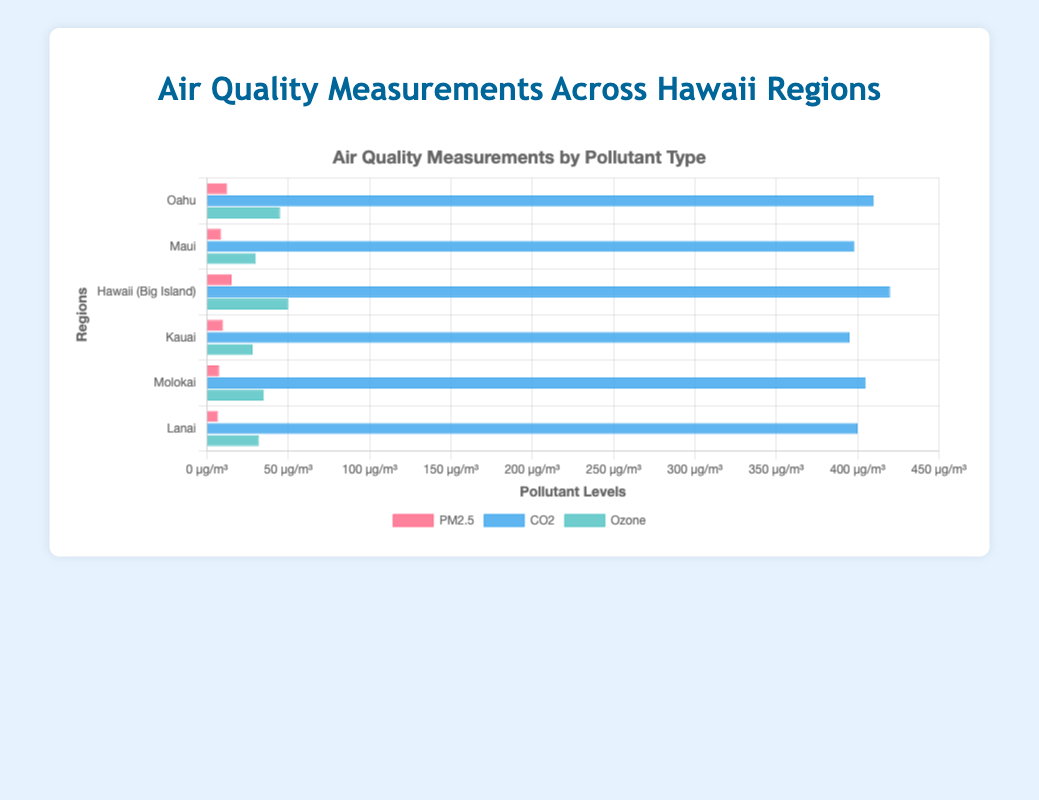Which region has the highest PM2.5 level? The highest PM2.5 level can be found by looking at the length of the red bars in the chart. The region with the longest red bar corresponds to the highest PM2.5 level.
Answer: Hawaii (Big Island) Which region has the lowest CO2 level? The lowest CO2 level can be identified by finding the shortest blue bar in the chart. This bar represents the CO2 level for each region.
Answer: Kauai Which pollutant has the highest value in Oahu? To find the highest pollutant value in Oahu, compare the lengths of the red, blue, and green bars for Oahu. The longest bar indicates the highest pollutant value.
Answer: CO2 What is the total PM2.5 level across all regions? Add the PM2.5 levels for all regions: 12.4 (Oahu) + 8.7 (Maui) + 15.1 (Hawaii) + 9.9 (Kauai) + 7.5 (Molokai) + 6.8 (Lanai) → 12.4 + 8.7 + 15.1 + 9.9 + 7.5 + 6.8 = 60.4
Answer: 60.4 Which region has the highest combined pollutant level (sum of PM2.5, CO2, and Ozone levels)? Calculate the combined pollutant level for each region by summing the PM2.5, CO2, and Ozone levels, then compare these sums: 
Oahu: 12.4 + 410 + 45 = 467.4
Maui: 8.7 + 398 + 30 = 436.7
Hawaii: 15.1 + 420 + 50 = 485.1
Kauai: 9.9 + 395 + 28 = 432.9
Molokai: 7.5 + 405 + 35 = 447.5
Lanai: 6.8 + 400 + 32 = 438.8
The highest combined level is for Hawaii (Big Island).
Answer: Hawaii (Big Island) Which region has a higher Ozone level, Maui or Molokai? Compare the lengths of the green bars representing Ozone levels for Maui and Molokai. Molokai's green bar is longer.
Answer: Molokai How much higher is the CO2 level on the Big Island compared to Oahu? Subtract the CO2 level for Oahu from the CO2 level for the Big Island: 420 - 410 = 10 ppm.
Answer: 10 ppm Which two regions have the most similar CO2 levels? Compare the lengths of the blue bars, then identify the regions with the closest lengths: Oahu (410) and Molokai (405) have the most similar values.
Answer: Oahu and Molokai What is the average Ozone level across all regions? Calculate the average Ozone level by summing all the Ozone levels and dividing by the number of regions: (45 + 30 + 50 + 28 + 35 + 32) / 6 = 220 / 6 ≈ 36.7
Answer: 36.7 